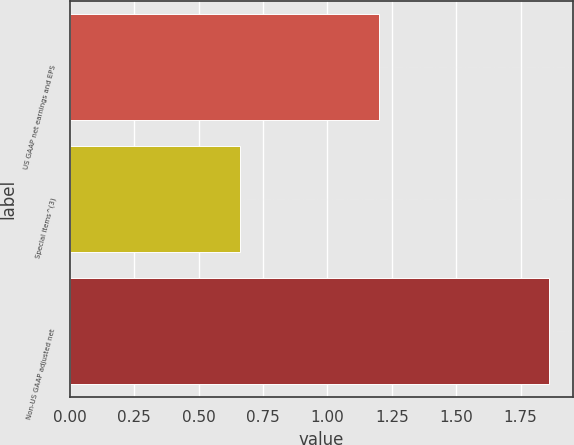Convert chart. <chart><loc_0><loc_0><loc_500><loc_500><bar_chart><fcel>US GAAP net earnings and EPS<fcel>Special items^(3)<fcel>Non-US GAAP adjusted net<nl><fcel>1.2<fcel>0.66<fcel>1.86<nl></chart> 